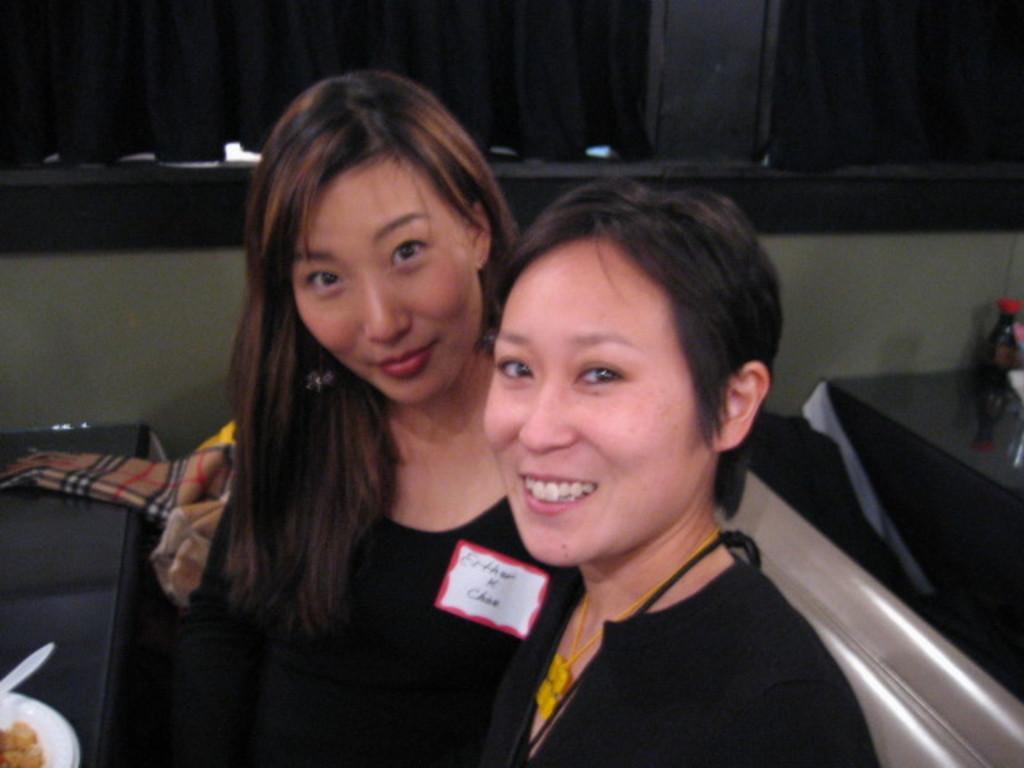Describe this image in one or two sentences. In this image we can see two ladies. There is a table on which there is a food item in a bowl. In the background of the image there is a black color curtain and wall. 